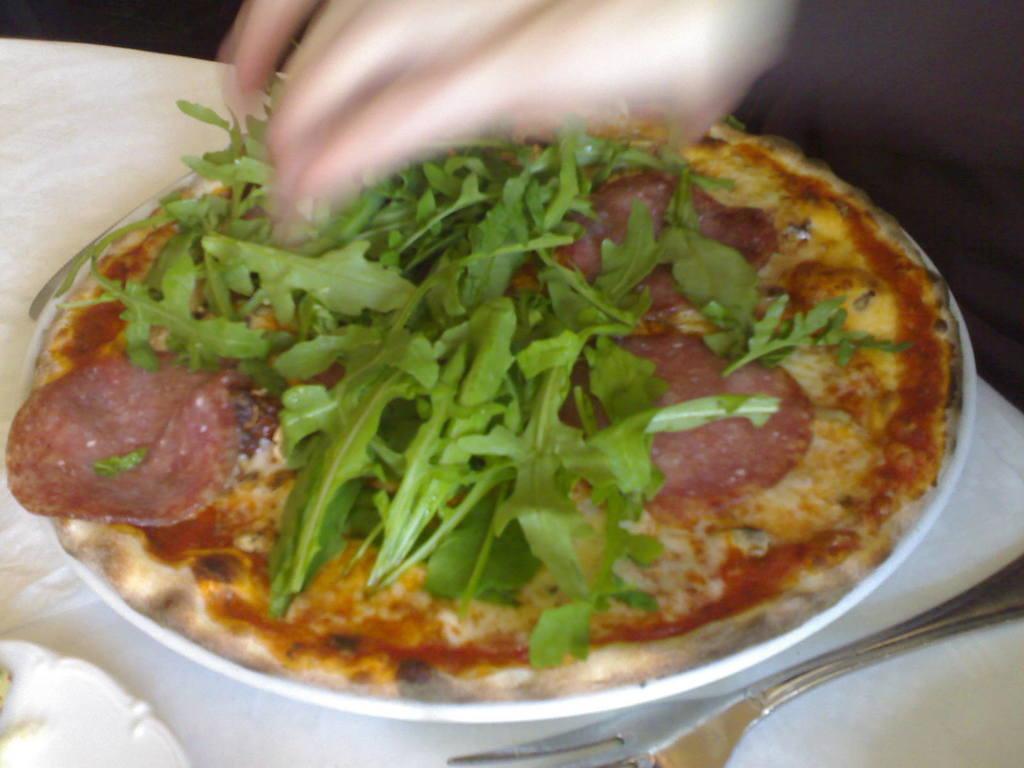In one or two sentences, can you explain what this image depicts? In this image there is a food item placed on a plate, which is on the table and beside the plate there is a fork, in front of the plate there is another plate. At the top of the image there is a hand of a person. 